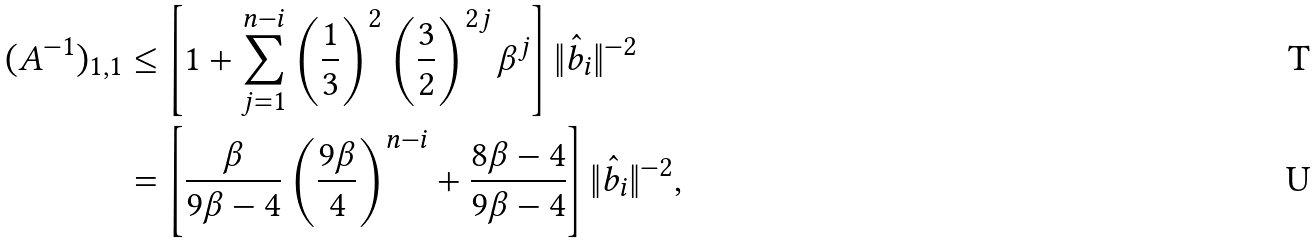Convert formula to latex. <formula><loc_0><loc_0><loc_500><loc_500>( A ^ { - 1 } ) _ { 1 , 1 } & \leq \left [ 1 + \sum _ { j = 1 } ^ { n - i } \left ( \frac { 1 } { 3 } \right ) ^ { 2 } \left ( \frac { 3 } { 2 } \right ) ^ { 2 j } \beta ^ { j } \right ] \| \hat { b } _ { i } \| ^ { - 2 } \\ & = \left [ \frac { \beta } { 9 \beta - 4 } \left ( \frac { 9 \beta } { 4 } \right ) ^ { n - i } + \frac { 8 \beta - 4 } { 9 \beta - 4 } \right ] \| \hat { b } _ { i } \| ^ { - 2 } ,</formula> 